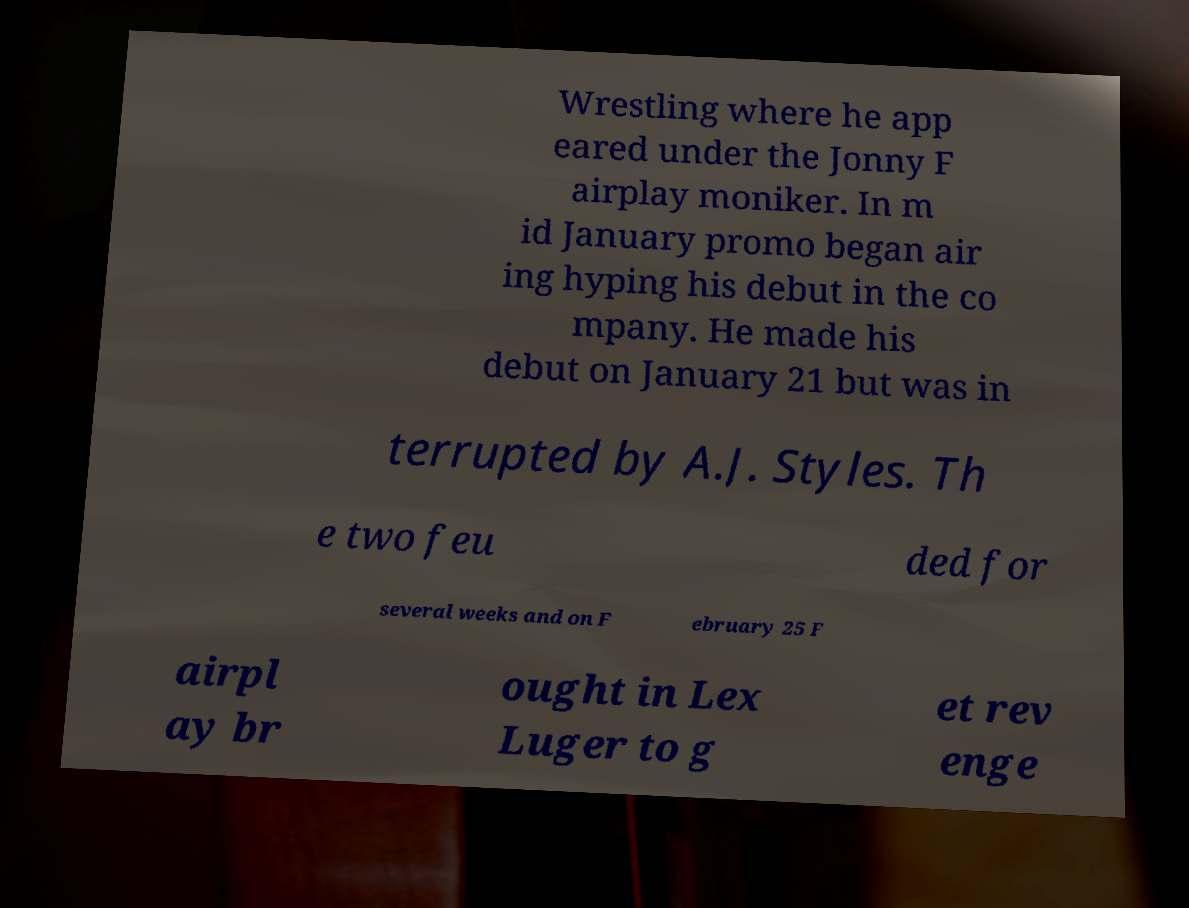Please identify and transcribe the text found in this image. Wrestling where he app eared under the Jonny F airplay moniker. In m id January promo began air ing hyping his debut in the co mpany. He made his debut on January 21 but was in terrupted by A.J. Styles. Th e two feu ded for several weeks and on F ebruary 25 F airpl ay br ought in Lex Luger to g et rev enge 